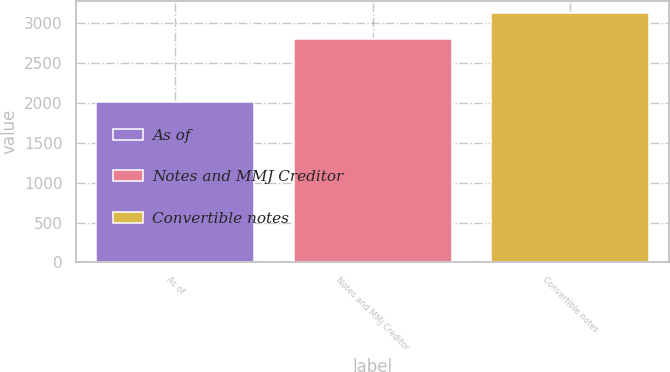Convert chart to OTSL. <chart><loc_0><loc_0><loc_500><loc_500><bar_chart><fcel>As of<fcel>Notes and MMJ Creditor<fcel>Convertible notes<nl><fcel>2018<fcel>2798<fcel>3124<nl></chart> 